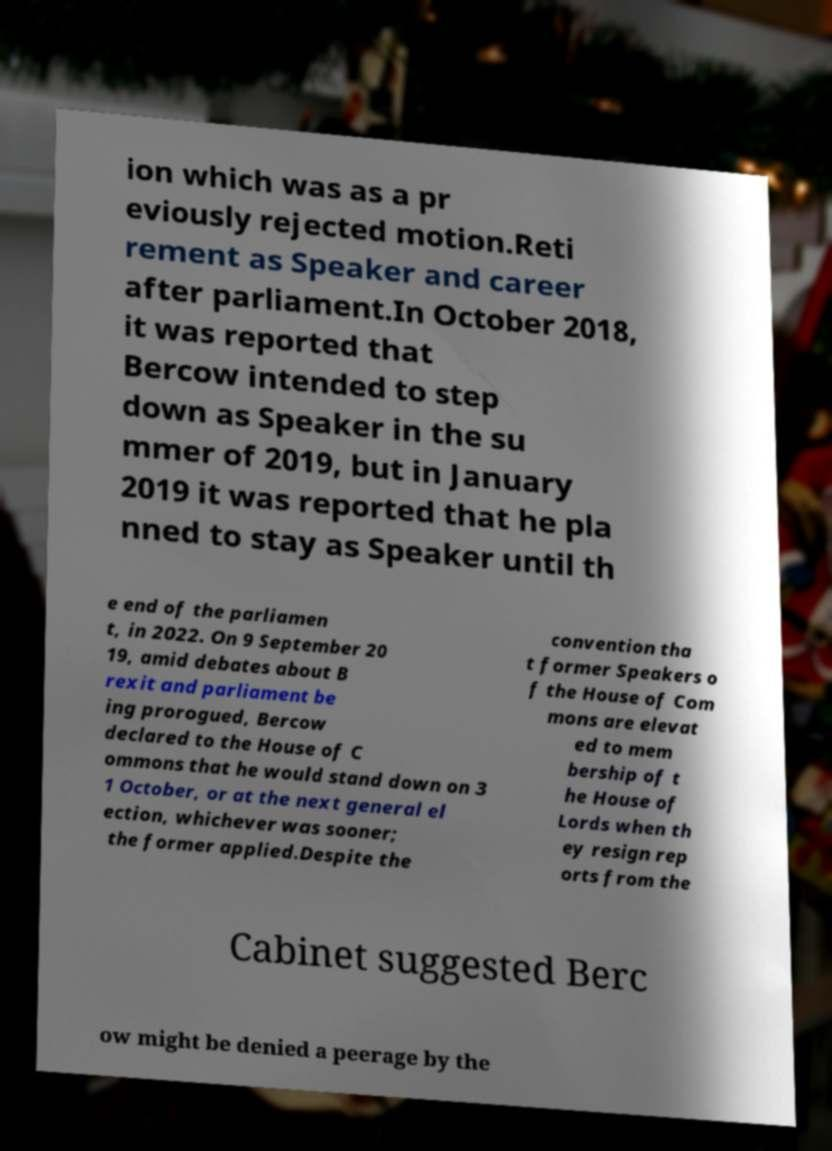I need the written content from this picture converted into text. Can you do that? ion which was as a pr eviously rejected motion.Reti rement as Speaker and career after parliament.In October 2018, it was reported that Bercow intended to step down as Speaker in the su mmer of 2019, but in January 2019 it was reported that he pla nned to stay as Speaker until th e end of the parliamen t, in 2022. On 9 September 20 19, amid debates about B rexit and parliament be ing prorogued, Bercow declared to the House of C ommons that he would stand down on 3 1 October, or at the next general el ection, whichever was sooner; the former applied.Despite the convention tha t former Speakers o f the House of Com mons are elevat ed to mem bership of t he House of Lords when th ey resign rep orts from the Cabinet suggested Berc ow might be denied a peerage by the 